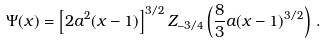<formula> <loc_0><loc_0><loc_500><loc_500>\Psi ( x ) = \left [ 2 a ^ { 2 } ( x - 1 ) \right ] ^ { 3 / 2 } Z _ { - 3 / 4 } \left ( \frac { 8 } { 3 } a ( x - 1 ) ^ { 3 / 2 } \right ) \, .</formula> 